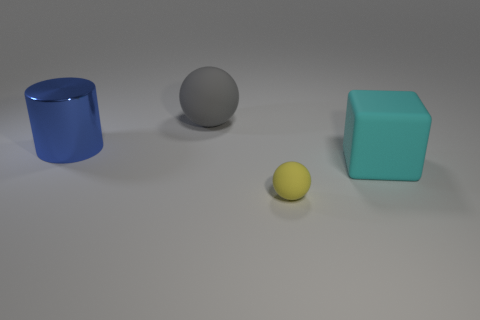How do the textures of the objects differ? The blue cylinder seems to have a smooth, perhaps metallic finish, reflecting light on its surface. The gray sphere appears to have a matte rubber texture, while the turquoise cube has a flat, even surface that might suggest a plastic material. The yellow sphere, being the smallest, has less discernible texture, but it could be matte like the gray sphere. 